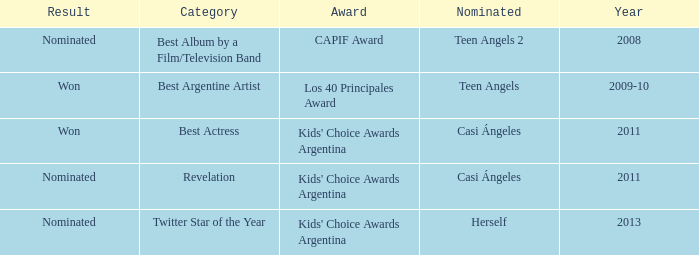In what category was Herself nominated? Twitter Star of the Year. 